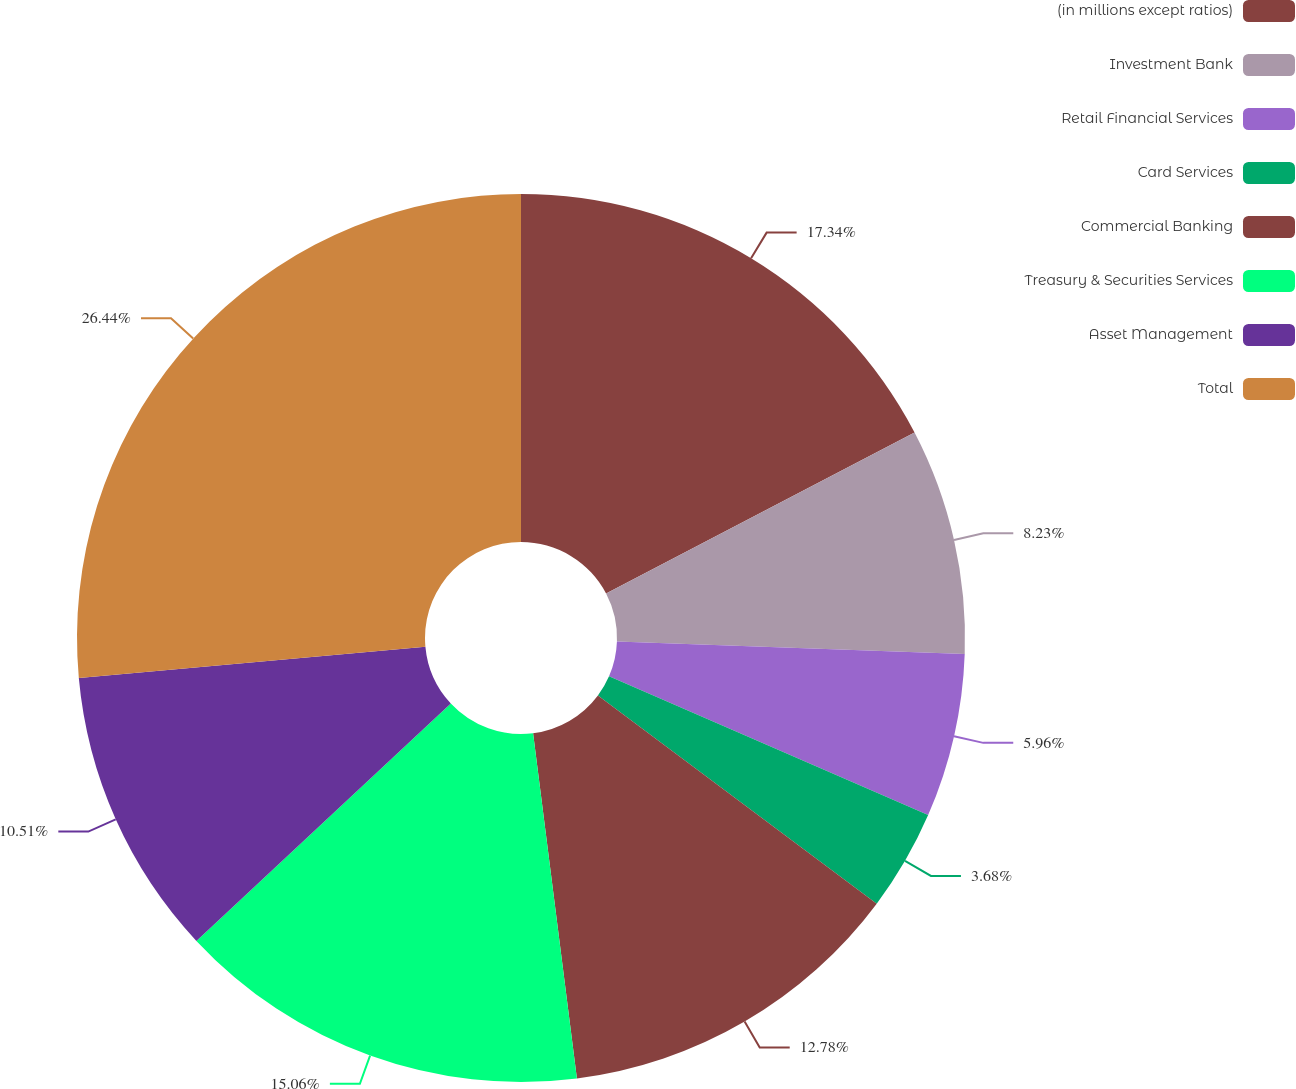<chart> <loc_0><loc_0><loc_500><loc_500><pie_chart><fcel>(in millions except ratios)<fcel>Investment Bank<fcel>Retail Financial Services<fcel>Card Services<fcel>Commercial Banking<fcel>Treasury & Securities Services<fcel>Asset Management<fcel>Total<nl><fcel>17.34%<fcel>8.23%<fcel>5.96%<fcel>3.68%<fcel>12.78%<fcel>15.06%<fcel>10.51%<fcel>26.44%<nl></chart> 